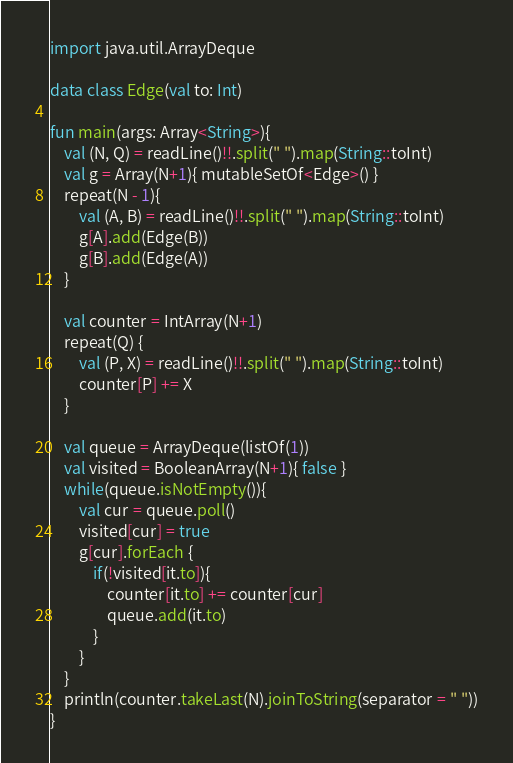<code> <loc_0><loc_0><loc_500><loc_500><_Kotlin_>import java.util.ArrayDeque

data class Edge(val to: Int)

fun main(args: Array<String>){
    val (N, Q) = readLine()!!.split(" ").map(String::toInt)
    val g = Array(N+1){ mutableSetOf<Edge>() }
    repeat(N - 1){
        val (A, B) = readLine()!!.split(" ").map(String::toInt)
        g[A].add(Edge(B))
        g[B].add(Edge(A))
    }
    
    val counter = IntArray(N+1)
    repeat(Q) {
        val (P, X) = readLine()!!.split(" ").map(String::toInt)
        counter[P] += X
    }

    val queue = ArrayDeque(listOf(1))
    val visited = BooleanArray(N+1){ false }
    while(queue.isNotEmpty()){
        val cur = queue.poll()
        visited[cur] = true
        g[cur].forEach {
            if(!visited[it.to]){
                counter[it.to] += counter[cur]
                queue.add(it.to)
            }
        }
    }
    println(counter.takeLast(N).joinToString(separator = " "))
}</code> 